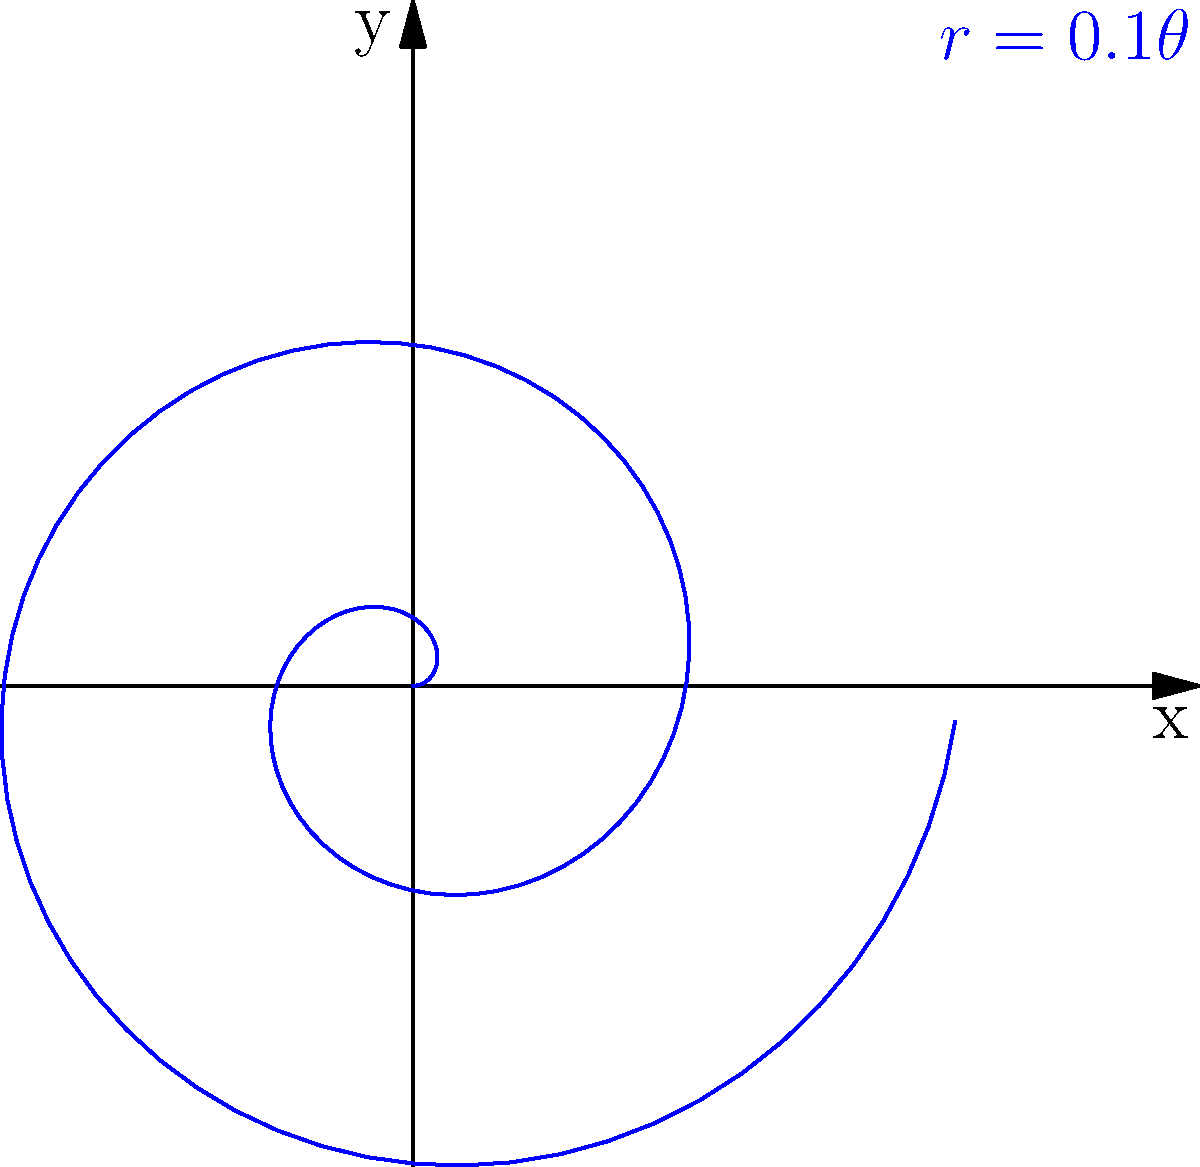Given the spiral shown in the polar plot, determine its equation. Then, calculate the radial distance from the origin when $\theta = 10\pi$. To solve this problem, let's break it down into steps:

1) Observe the spiral:
   The spiral starts at the origin and gradually increases its distance from the center as $\theta$ increases.

2) Identify the equation:
   The equation of this type of spiral is of the form $r = a\theta$, where $a$ is a constant that determines how tightly the spiral is wound.

3) Determine the constant $a$:
   From the label on the graph, we can see that $r = 0.1\theta$.

4) Verify the equation:
   $r = 0.1\theta$ matches the given spiral, as it starts at the origin (when $\theta = 0$, $r = 0$) and grows linearly with $\theta$.

5) Calculate the radial distance when $\theta = 10\pi$:
   Substitute $\theta = 10\pi$ into the equation:
   $r = 0.1(10\pi) = \pi$

Therefore, when $\theta = 10\pi$, the radial distance from the origin is $\pi$.
Answer: $r = 0.1\theta$; $\pi$ 